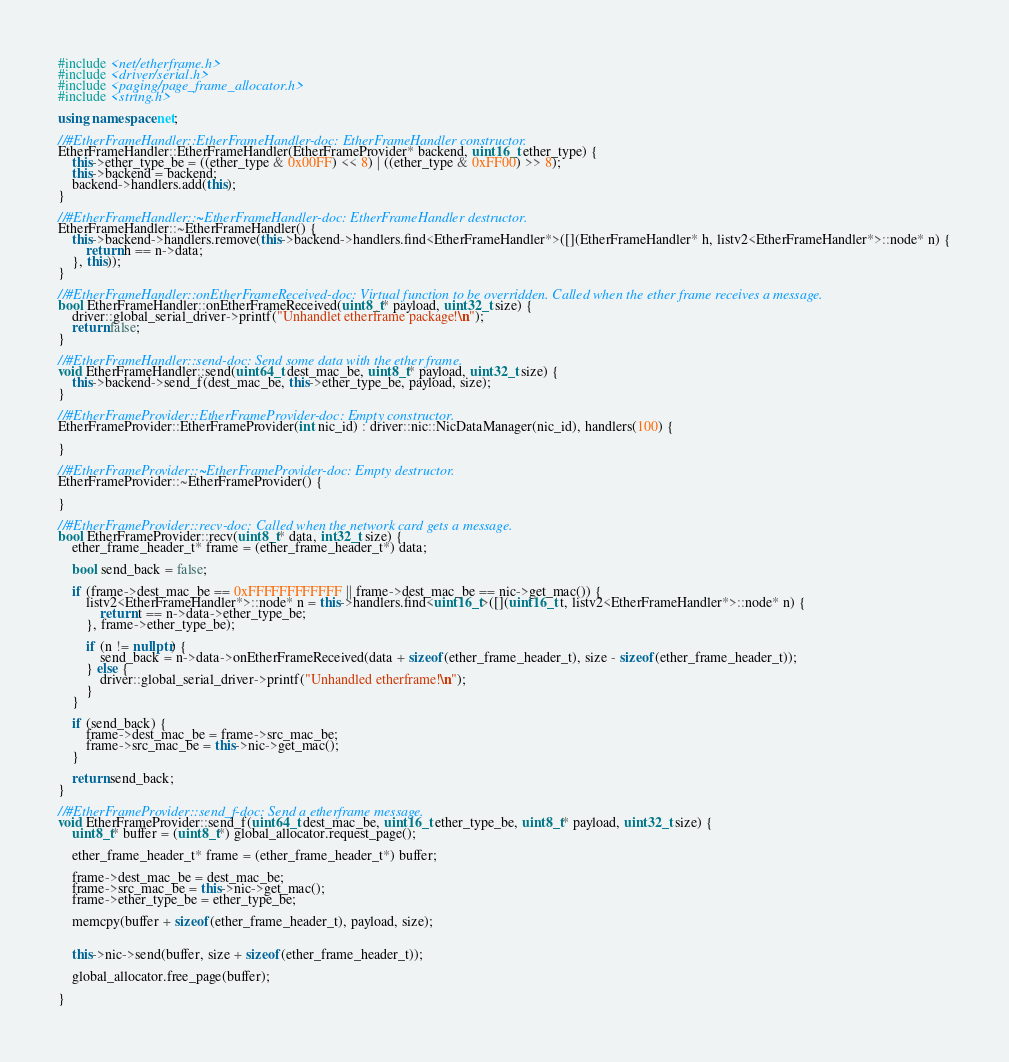Convert code to text. <code><loc_0><loc_0><loc_500><loc_500><_C++_>#include <net/etherframe.h>
#include <driver/serial.h>
#include <paging/page_frame_allocator.h>
#include <string.h>

using namespace net;

//#EtherFrameHandler::EtherFrameHandler-doc: EtherFrameHandler constructor.
EtherFrameHandler::EtherFrameHandler(EtherFrameProvider* backend, uint16_t ether_type) {
	this->ether_type_be = ((ether_type & 0x00FF) << 8) | ((ether_type & 0xFF00) >> 8);
	this->backend = backend;
	backend->handlers.add(this);
}

//#EtherFrameHandler::~EtherFrameHandler-doc: EtherFrameHandler destructor.
EtherFrameHandler::~EtherFrameHandler() {
	this->backend->handlers.remove(this->backend->handlers.find<EtherFrameHandler*>([](EtherFrameHandler* h, listv2<EtherFrameHandler*>::node* n) {
		return h == n->data;
	}, this));
}

//#EtherFrameHandler::onEtherFrameReceived-doc: Virtual function to be overridden. Called when the ether frame receives a message.
bool EtherFrameHandler::onEtherFrameReceived(uint8_t* payload, uint32_t size) {
	driver::global_serial_driver->printf("Unhandlet etherframe package!\n");
	return false;
}

//#EtherFrameHandler::send-doc: Send some data with the ether frame.
void EtherFrameHandler::send(uint64_t dest_mac_be, uint8_t* payload, uint32_t size) {
	this->backend->send_f(dest_mac_be, this->ether_type_be, payload, size);
}

//#EtherFrameProvider::EtherFrameProvider-doc: Empty constructor.
EtherFrameProvider::EtherFrameProvider(int nic_id) : driver::nic::NicDataManager(nic_id), handlers(100) {

}

//#EtherFrameProvider::~EtherFrameProvider-doc: Empty destructor.
EtherFrameProvider::~EtherFrameProvider() {

}

//#EtherFrameProvider::recv-doc: Called when the network card gets a message.
bool EtherFrameProvider::recv(uint8_t* data, int32_t size) {
	ether_frame_header_t* frame = (ether_frame_header_t*) data;

	bool send_back = false;

	if (frame->dest_mac_be == 0xFFFFFFFFFFFF || frame->dest_mac_be == nic->get_mac()) {
		listv2<EtherFrameHandler*>::node* n = this->handlers.find<uint16_t>([](uint16_t t, listv2<EtherFrameHandler*>::node* n) {
			return t == n->data->ether_type_be;
		}, frame->ether_type_be);

		if (n != nullptr) {
			send_back = n->data->onEtherFrameReceived(data + sizeof(ether_frame_header_t), size - sizeof(ether_frame_header_t));
		} else {
			driver::global_serial_driver->printf("Unhandled etherframe!\n");
		}
	}

	if (send_back) {
		frame->dest_mac_be = frame->src_mac_be;
		frame->src_mac_be = this->nic->get_mac();
	}

	return send_back;
}

//#EtherFrameProvider::send_f-doc: Send a etherframe message.
void EtherFrameProvider::send_f(uint64_t dest_mac_be, uint16_t ether_type_be, uint8_t* payload, uint32_t size) {
	uint8_t* buffer = (uint8_t*) global_allocator.request_page();

	ether_frame_header_t* frame = (ether_frame_header_t*) buffer;

	frame->dest_mac_be = dest_mac_be;
	frame->src_mac_be = this->nic->get_mac();
	frame->ether_type_be = ether_type_be;

	memcpy(buffer + sizeof(ether_frame_header_t), payload, size);


	this->nic->send(buffer, size + sizeof(ether_frame_header_t));

	global_allocator.free_page(buffer);

}</code> 